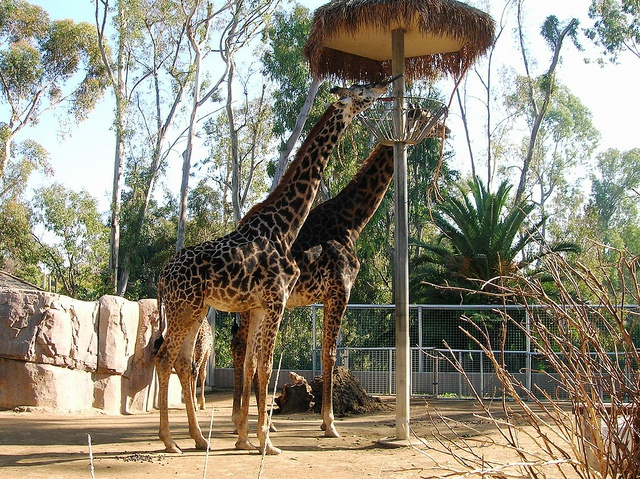Describe the objects in this image and their specific colors. I can see giraffe in lightgray, black, maroon, and brown tones, giraffe in lightgray, black, maroon, and gray tones, and giraffe in lightgray, beige, tan, gray, and brown tones in this image. 